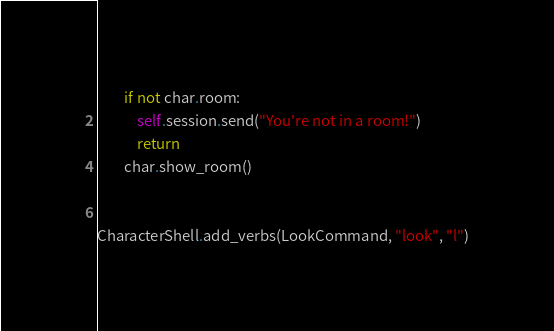<code> <loc_0><loc_0><loc_500><loc_500><_Python_>        if not char.room:
            self.session.send("You're not in a room!")
            return
        char.show_room()


CharacterShell.add_verbs(LookCommand, "look", "l")
</code> 